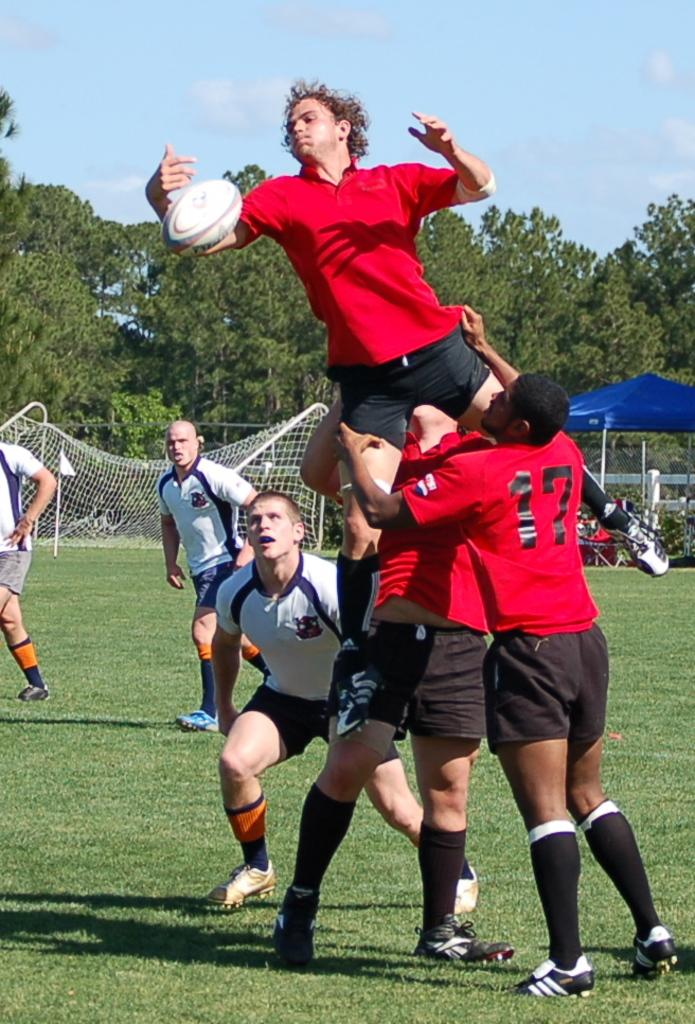What are the people in the image doing? The people in the image are in motion, which suggests they might be playing a game or engaging in some form of physical activity. What is happening with the ball in the image? The ball is in the air, which could be a result of someone kicking or throwing it. What type of terrain is visible in the image? There is grass visible in the image, which indicates that the setting is likely outdoors. What structures can be seen in the background of the image? There is a tent and a net in the background of the image, which suggests that the activity taking place might be a sport or game. What other natural elements are present in the background of the image? There are plants, trees, and the sky visible in the background of the image, which adds to the outdoor setting. What is the title of the book that the crook is reading in the image? There is no crook or book present in the image; it features people playing a game or engaging in physical activity outdoors. 